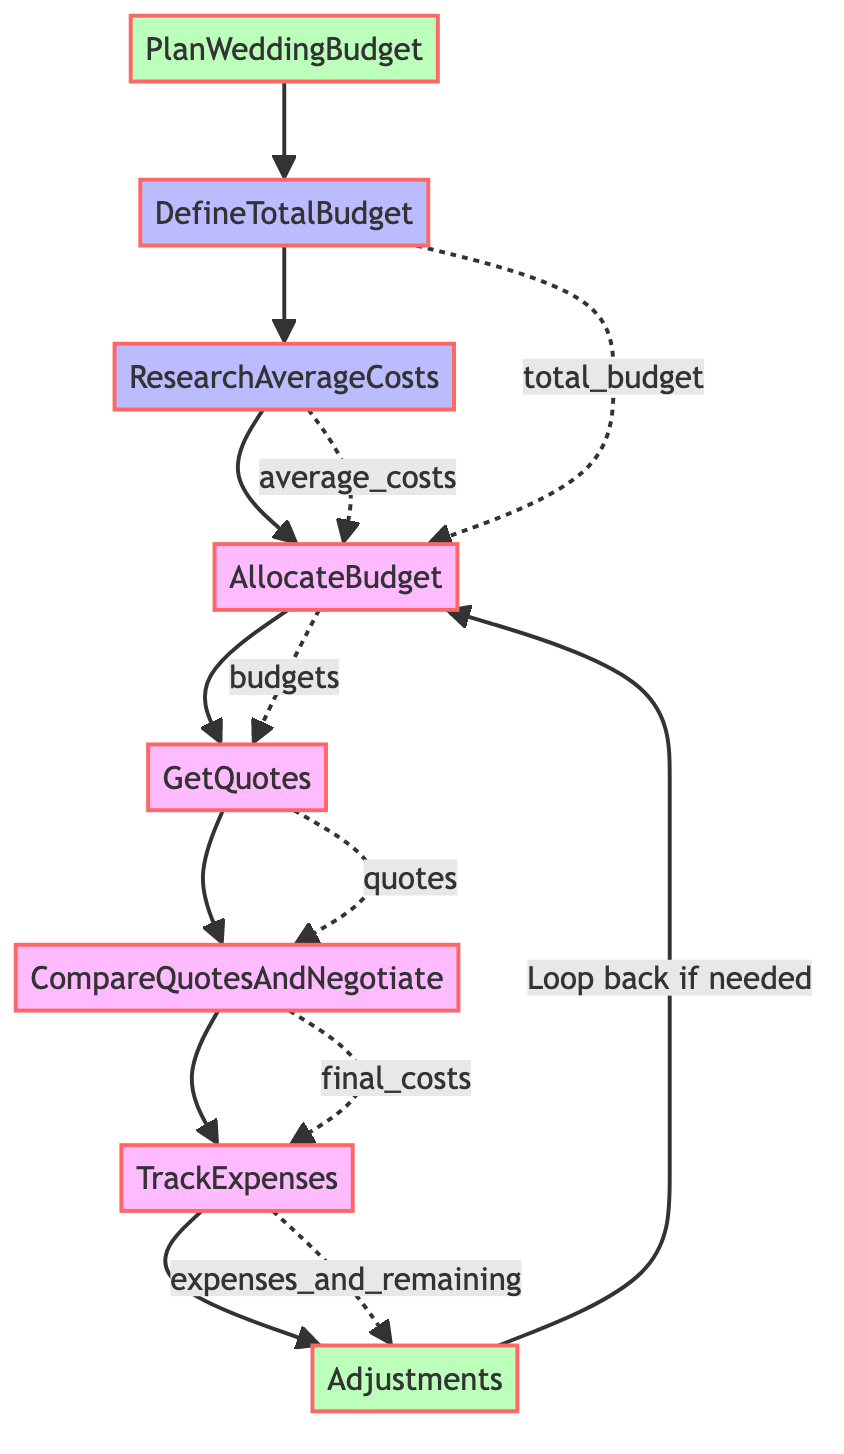What is the first step in the process? The first step in the process is defined as "DefineTotalBudget," which aims to determine the overall amount of money available for the wedding.
Answer: DefineTotalBudget How many total steps are there in the flowchart? The flowchart consists of 8 steps, including the initial and final steps in the process.
Answer: 8 Which step follows "GetQuotes"? Following "GetQuotes," the next step is "CompareQuotesAndNegotiate," where the obtained quotes are compared and better deals are negotiated if possible.
Answer: CompareQuotesAndNegotiate What is the role of the final step in the budget planning process? The final step "Adjustments" allows for making necessary changes to the budget allocation based on actual expenses. This step can loop back to "AllocateBudget" if adjustments are needed.
Answer: Adjustments What connects "TrackExpenses" to "Adjustments"? "TrackExpenses" connects to "Adjustments" through the notion of tracking total expenses and determining the remaining budget to inform any necessary adjustments based on that data.
Answer: expenses_and_remaining How is the "total_budget" used in the flowchart? The "total_budget" variable is utilized in the "DefineTotalBudget" step to establish the overall budget and then influences the "AllocateBudget" step, where various portions of the total budget are allocated.
Answer: DefineTotalBudget Which step requires research on average costs? The step that requires research on average costs is "ResearchAverageCosts," wherein various costs associated with different wedding elements are examined and gathered.
Answer: ResearchAverageCosts What does the loop in the flowchart indicate? The loop in the flowchart indicates that after "Adjustments," if necessary, the process can return to "AllocateBudget" to revise the budget allocations based on actual expenses counted.
Answer: Loop back if needed 